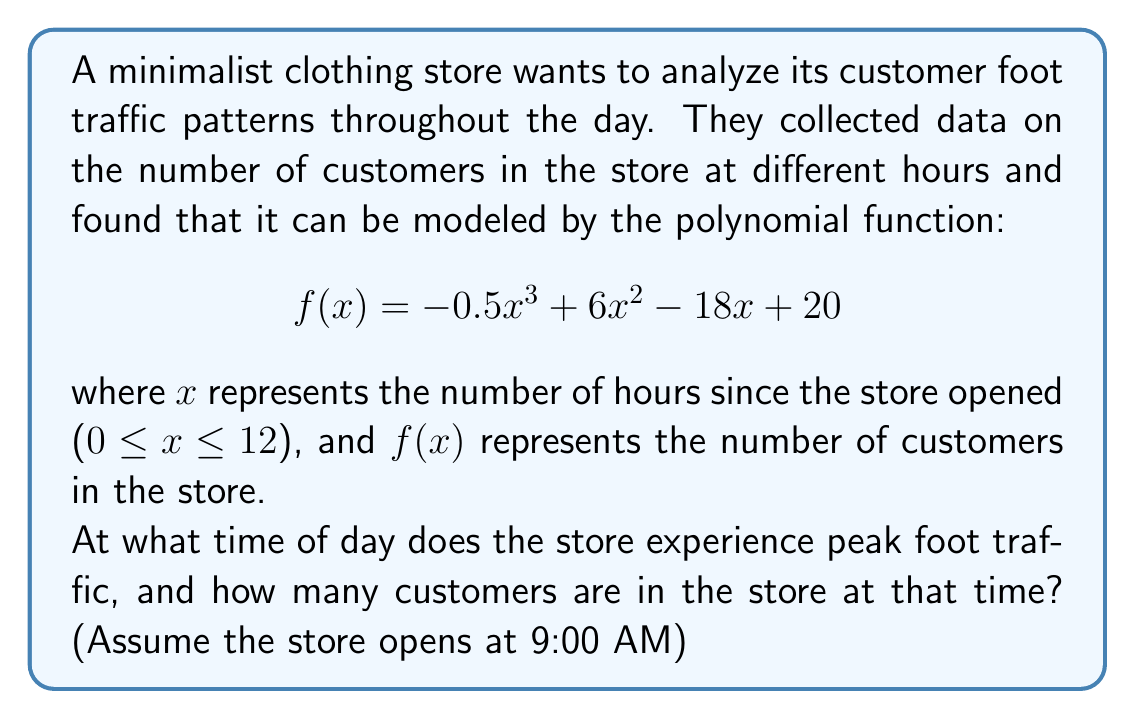Solve this math problem. To find the peak foot traffic, we need to determine the maximum of the function $f(x)$. This occurs where the derivative $f'(x) = 0$.

Step 1: Find the derivative of $f(x)$
$$f'(x) = -1.5x^2 + 12x - 18$$

Step 2: Set $f'(x) = 0$ and solve for x
$$-1.5x^2 + 12x - 18 = 0$$

Step 3: Use the quadratic formula to solve this equation
$$x = \frac{-b \pm \sqrt{b^2 - 4ac}}{2a}$$
where $a = -1.5$, $b = 12$, and $c = -18$

$$x = \frac{-12 \pm \sqrt{12^2 - 4(-1.5)(-18)}}{2(-1.5)}$$
$$x = \frac{-12 \pm \sqrt{144 - 108}}{-3}$$
$$x = \frac{-12 \pm \sqrt{36}}{-3} = \frac{-12 \pm 6}{-3}$$

This gives us two solutions: $x = 2$ or $x = 4$

Step 4: Check the second derivative to determine which solution is the maximum
$$f''(x) = -3x + 12$$
At $x = 2$: $f''(2) = -3(2) + 12 = 6 > 0$ (This is a minimum)
At $x = 4$: $f''(4) = -3(4) + 12 = -12 < 0$ (This is a maximum)

Therefore, the peak foot traffic occurs at $x = 4$ hours after opening.

Step 5: Calculate the number of customers at peak time
$$f(4) = -0.5(4)^3 + 6(4)^2 - 18(4) + 20 = -32 + 96 - 72 + 20 = 12$$

Step 6: Convert the time to clock time
The store opens at 9:00 AM, so 4 hours later is 1:00 PM.
Answer: 1:00 PM; 12 customers 